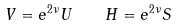<formula> <loc_0><loc_0><loc_500><loc_500>V = e ^ { 2 \nu } U \quad H = e ^ { 2 \nu } S</formula> 